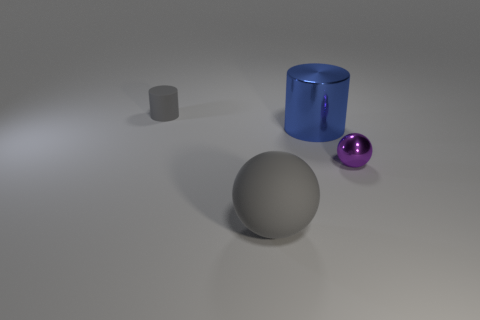Add 1 tiny purple spheres. How many objects exist? 5 Subtract 0 brown cylinders. How many objects are left? 4 Subtract all large metallic objects. Subtract all matte spheres. How many objects are left? 2 Add 4 gray objects. How many gray objects are left? 6 Add 2 tiny purple balls. How many tiny purple balls exist? 3 